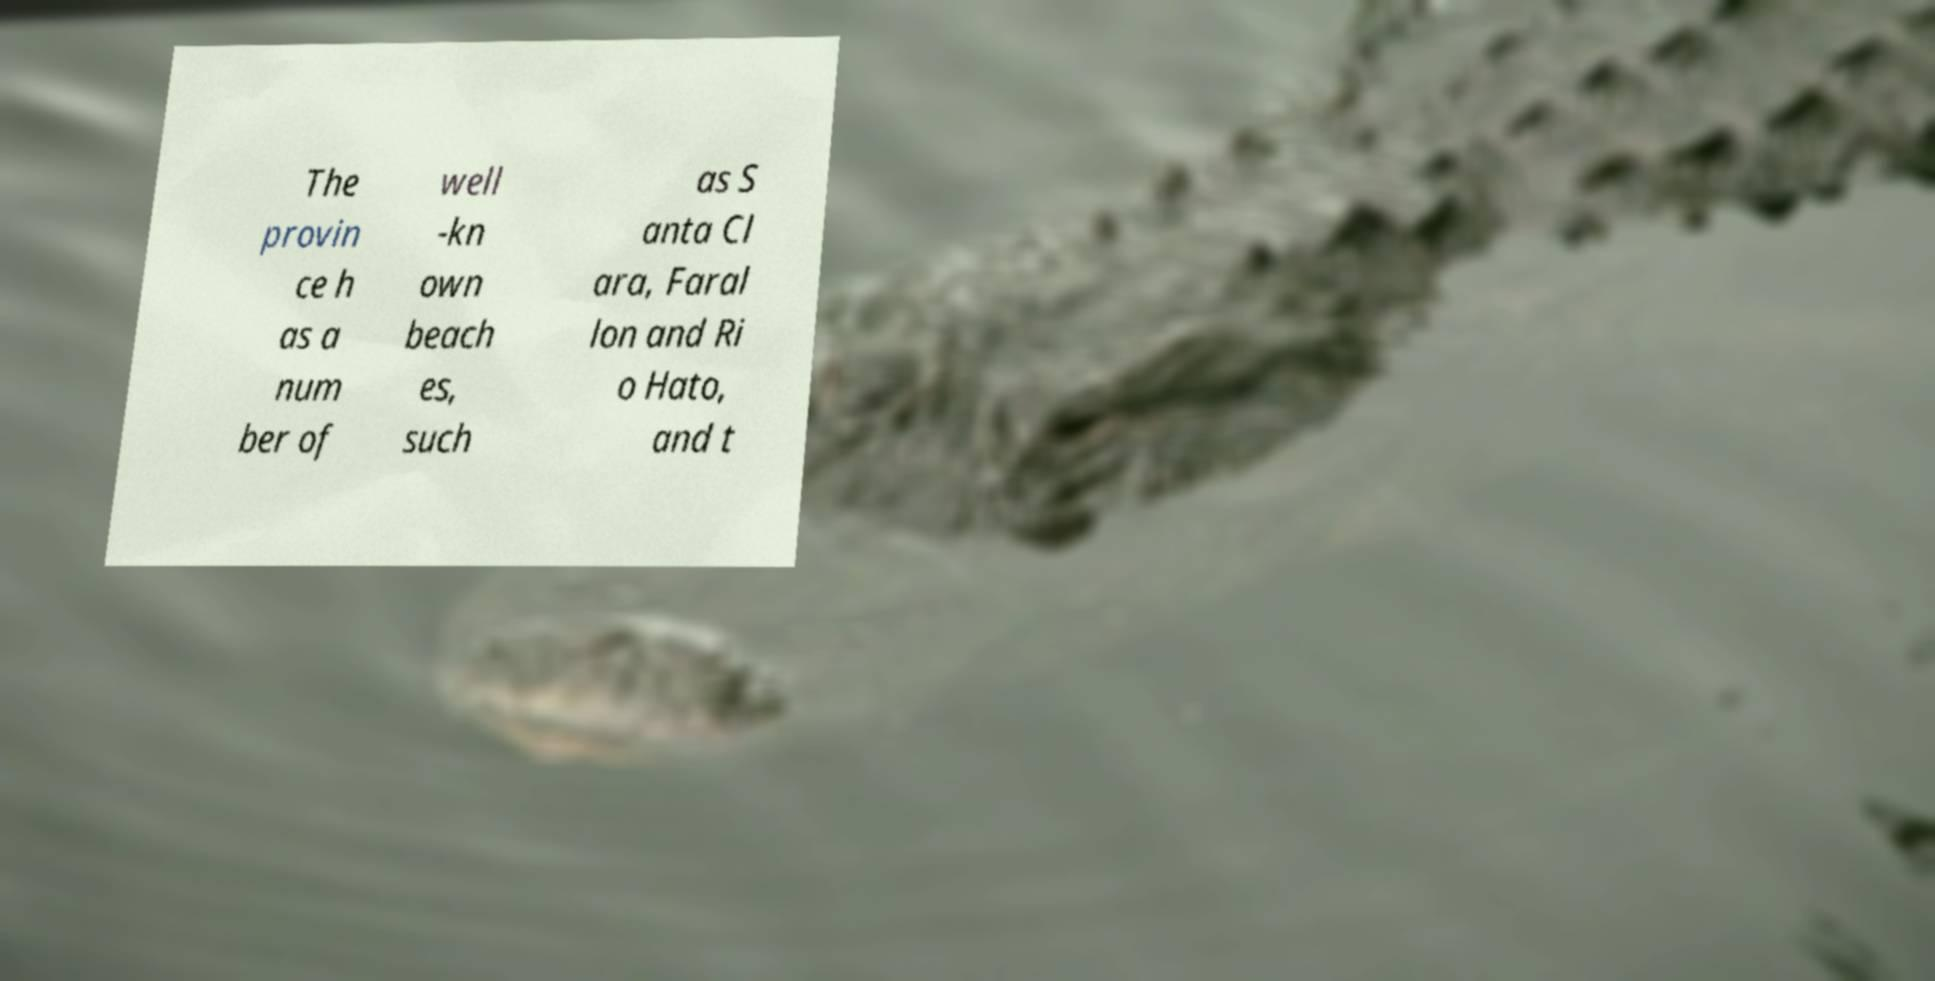For documentation purposes, I need the text within this image transcribed. Could you provide that? The provin ce h as a num ber of well -kn own beach es, such as S anta Cl ara, Faral lon and Ri o Hato, and t 